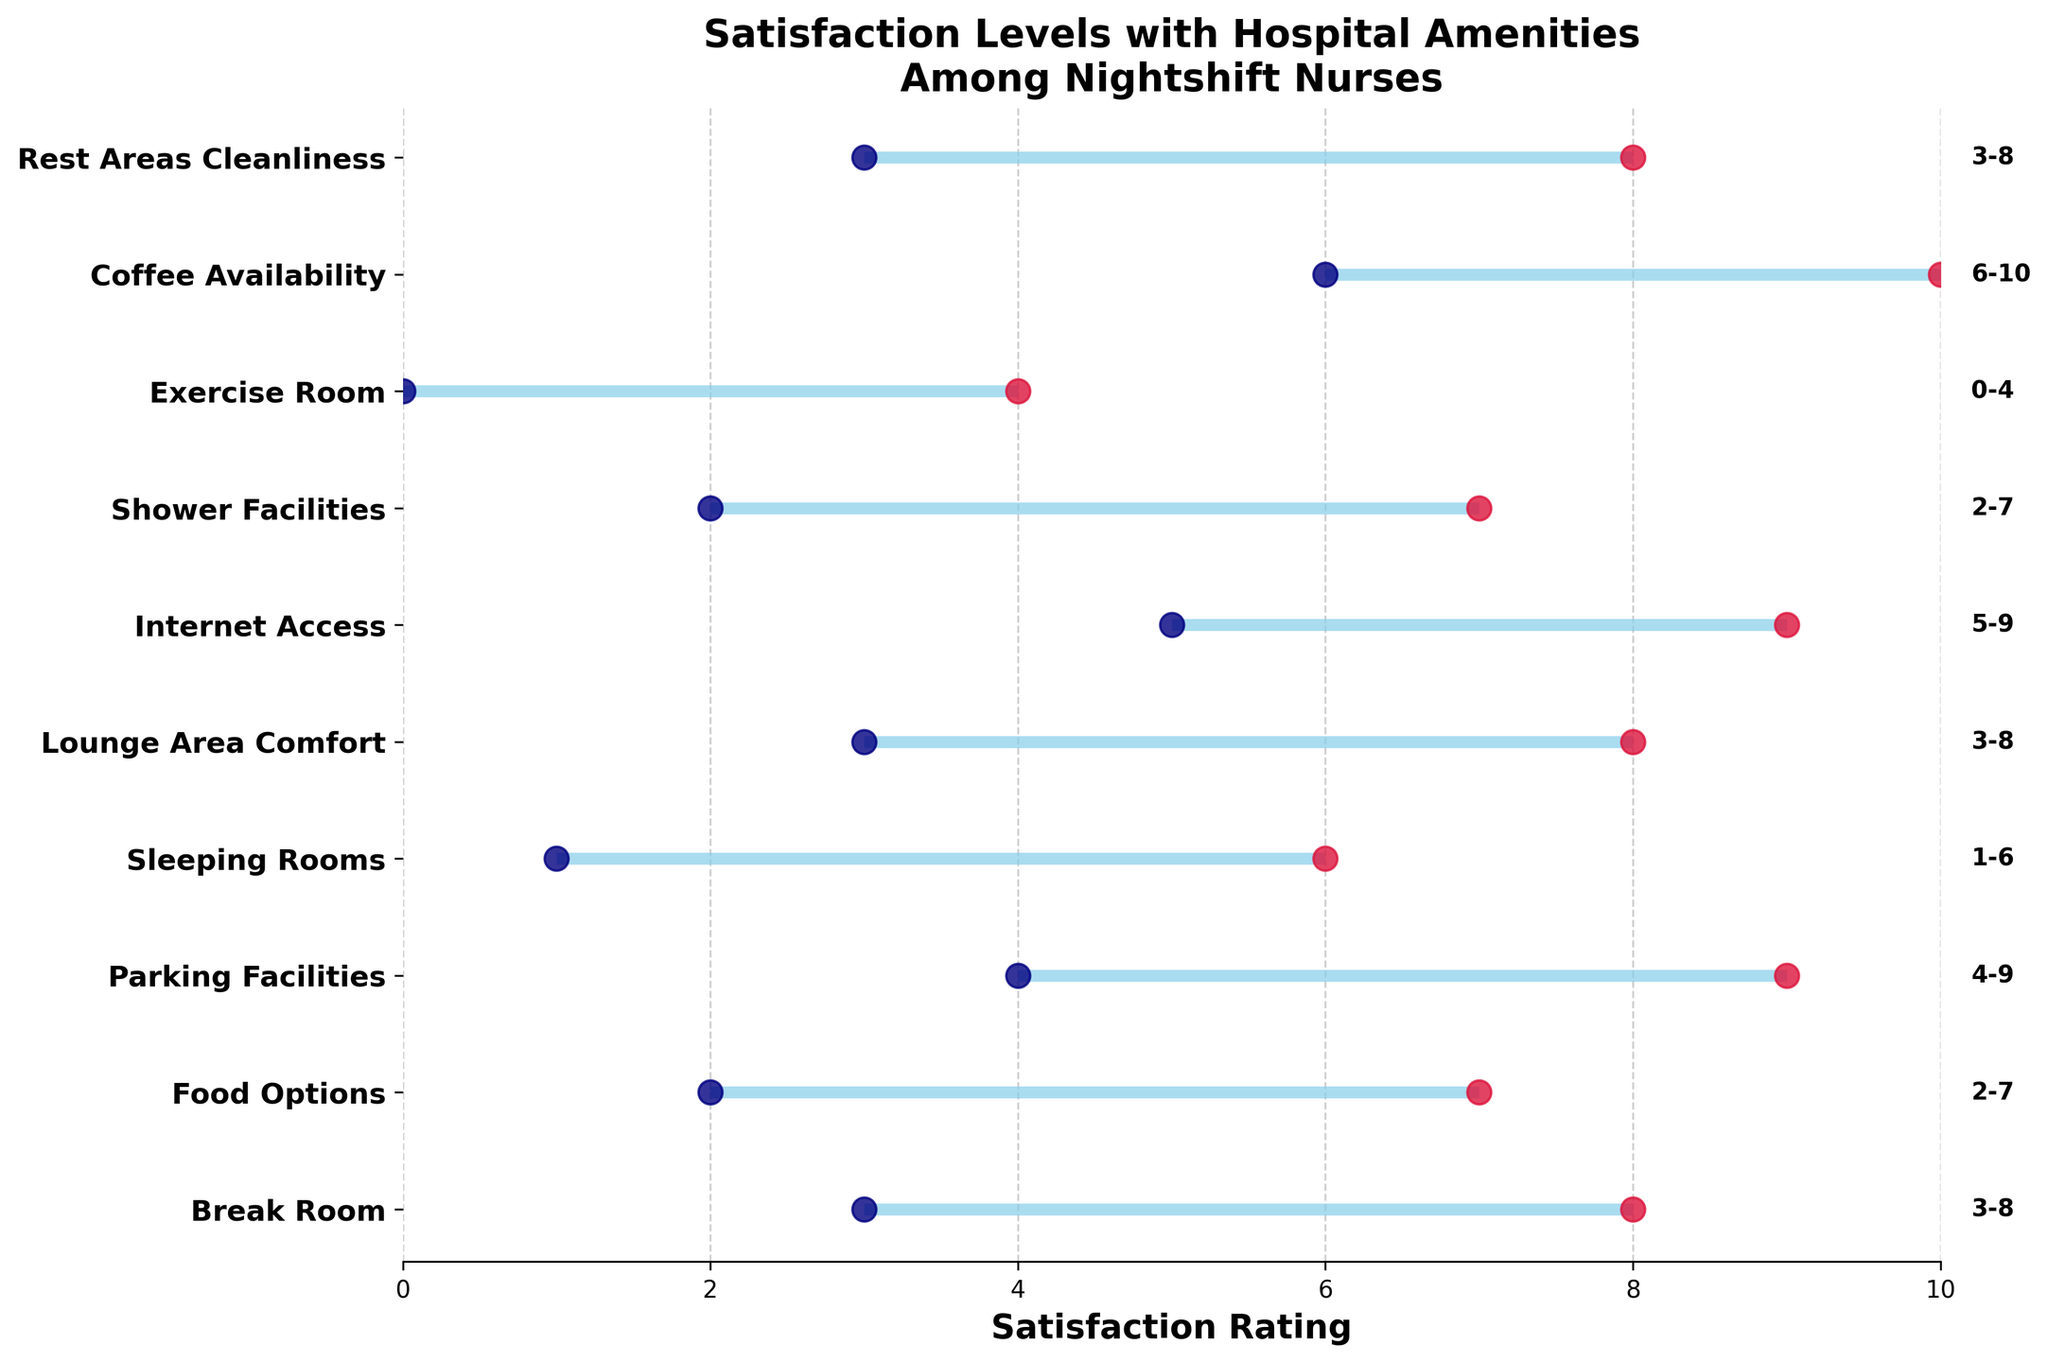What is the range of satisfaction ratings for Internet Access? The figure shows the minimum and maximum ratings for each amenity. For Internet Access, the blue dot represents the minimum rating and the red dot represents the maximum rating, placed horizontally along the satisfaction rating axis. The range is between 5 and 9.
Answer: 5-9 Which amenity has the highest maximum satisfaction rating? By checking the highest point on the satisfaction rating axis, we can see that the Coffee Availability amenity has the highest maximum rating indicated by the red dot at 10.
Answer: Coffee Availability What are the maximum and minimum ratings for the Break Room? The Break Room's satisfaction levels are marked with a horizontal line intersecting both a blue dot (minimum) and a red dot (maximum) on the satisfaction rating axis. The minimum rating is 3 and the maximum rating is 8.
Answer: Minimum: 3, Maximum: 8 Which amenity received the lowest minimum satisfaction rating? The lowest point on the satisfaction rating axis is found by looking for the blue dot closest to the zero mark. The Exercise Room has the lowest minimum rating, which is 0.
Answer: Exercise Room Which amenities have a satisfaction rating range that starts at 3? To find out which amenities start from a satisfaction rating of 3, look for horizontal lines beginning at 3 on the satisfaction rating axis, indicated by blue dots. These amenities are the Break Room, Lounge Area Comfort, and Rest Areas Cleanliness.
Answer: Break Room, Lounge Area Comfort, Rest Areas Cleanliness Which amenity has the widest range of satisfaction ratings? The widest range can be determined by finding the longest horizontal line in the plot, which is the distance between the blue and red dots for a given amenity. Exercise Room has the widest range from 0 to 4, which is a span of 4.
Answer: Exercise Room Compare the maximum satisfaction ratings for Food Options and Shower Facilities. Which one is higher? By locating the red dots for both amenities on the satisfaction rating axis, the maximum rating for Food Options is 7 and for Shower Facilities it is also 7. Both amenities have the same maximum satisfaction rating.
Answer: Food Options and Shower Facilities (equal) What's the average rating range for Shower Facilities? The satisfaction ratings for Shower Facilities are from 2 to 7. The average of this range can be calculated by adding the minimum and maximum rating and dividing by 2: (2 + 7) / 2 = 4.5.
Answer: 4.5 Which amenity has the smallest range of satisfaction ratings and what is it? The smallest range can be found by identifying the shortest horizontal line in the plot. Exercise Room has the smallest range, indicated by its shortest line from 0 to 4, but for the most precise and smallest range, we would also compare others if there is exact matches.
Answer: Exercise Room, range 4 